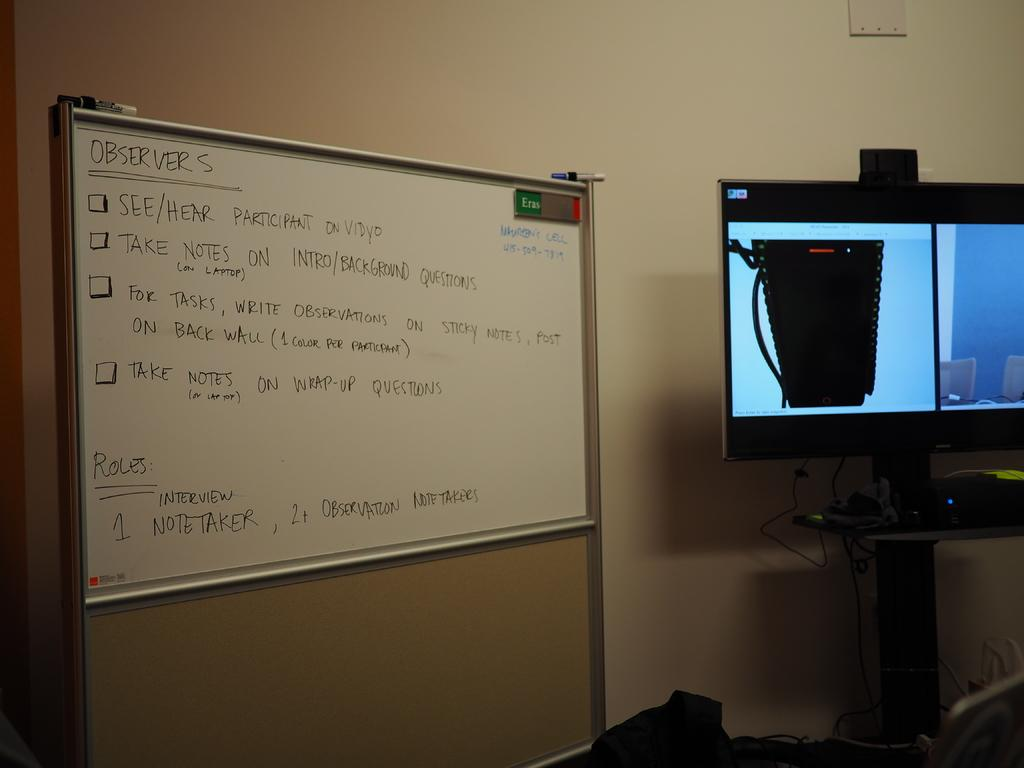<image>
Render a clear and concise summary of the photo. Words on a smart board with one of the instructions take notes on wrap-up questions. 